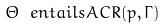<formula> <loc_0><loc_0><loc_500><loc_500>\Theta \ e n t a i l s A C R ( p , \Gamma )</formula> 